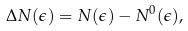Convert formula to latex. <formula><loc_0><loc_0><loc_500><loc_500>\Delta N ( \epsilon ) = N ( \epsilon ) - N ^ { 0 } ( \epsilon ) ,</formula> 